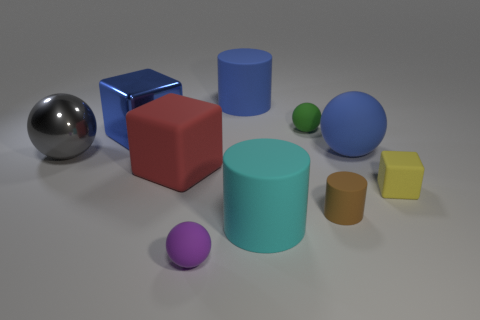Subtract all balls. How many objects are left? 6 Add 7 red things. How many red things exist? 8 Subtract 0 green cubes. How many objects are left? 10 Subtract all big brown metal spheres. Subtract all gray objects. How many objects are left? 9 Add 7 yellow matte things. How many yellow matte things are left? 8 